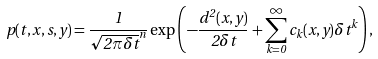<formula> <loc_0><loc_0><loc_500><loc_500>p ( t , x , s , y ) = \frac { 1 } { \sqrt { 2 \pi \delta t } ^ { n } } \exp \left ( - \frac { d ^ { 2 } ( x , y ) } { 2 \delta t } + \sum _ { k = 0 } ^ { \infty } c _ { k } ( x , y ) \delta t ^ { k } \right ) ,</formula> 